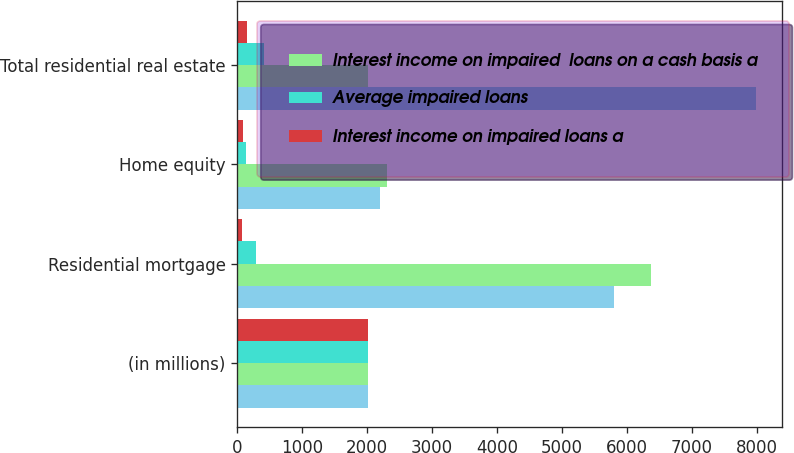<chart> <loc_0><loc_0><loc_500><loc_500><stacked_bar_chart><ecel><fcel>(in millions)<fcel>Residential mortgage<fcel>Home equity<fcel>Total residential real estate<nl><fcel>nan<fcel>2017<fcel>5797<fcel>2189<fcel>7986<nl><fcel>Interest income on impaired  loans on a cash basis a<fcel>2016<fcel>6376<fcel>2311<fcel>2017<nl><fcel>Average impaired loans<fcel>2017<fcel>287<fcel>127<fcel>414<nl><fcel>Interest income on impaired loans a<fcel>2017<fcel>75<fcel>80<fcel>155<nl></chart> 